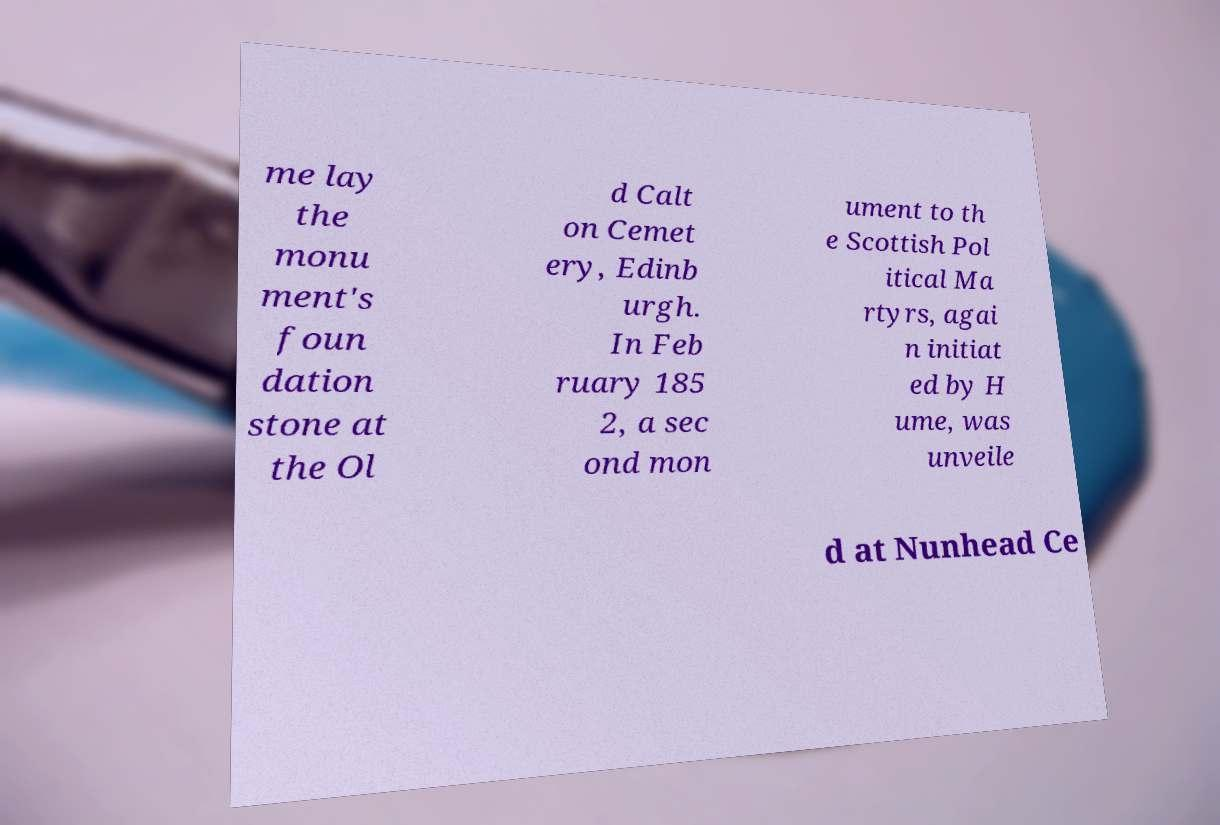Can you accurately transcribe the text from the provided image for me? me lay the monu ment's foun dation stone at the Ol d Calt on Cemet ery, Edinb urgh. In Feb ruary 185 2, a sec ond mon ument to th e Scottish Pol itical Ma rtyrs, agai n initiat ed by H ume, was unveile d at Nunhead Ce 